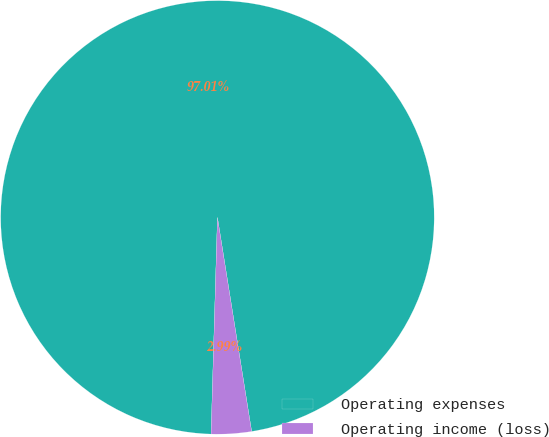Convert chart to OTSL. <chart><loc_0><loc_0><loc_500><loc_500><pie_chart><fcel>Operating expenses<fcel>Operating income (loss)<nl><fcel>97.01%<fcel>2.99%<nl></chart> 